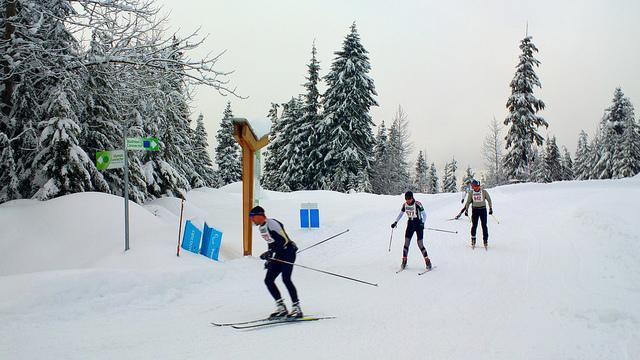How many people?
Give a very brief answer. 3. How many skiers are in this photo?
Give a very brief answer. 3. 